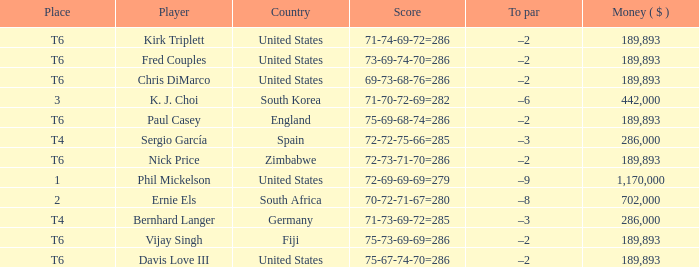What is the least money ($) when the country is united states and the player is kirk triplett? 189893.0. 